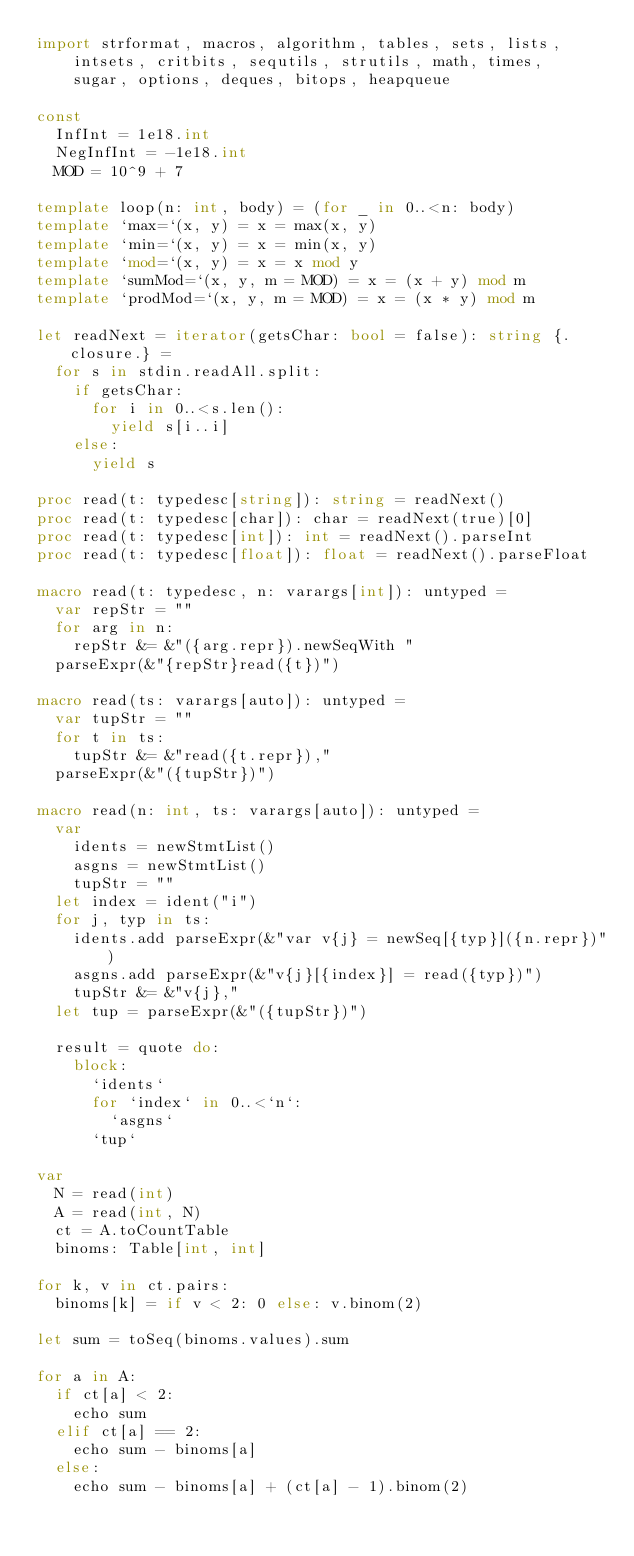Convert code to text. <code><loc_0><loc_0><loc_500><loc_500><_Nim_>import strformat, macros, algorithm, tables, sets, lists,
    intsets, critbits, sequtils, strutils, math, times,
    sugar, options, deques, bitops, heapqueue

const
  InfInt = 1e18.int
  NegInfInt = -1e18.int
  MOD = 10^9 + 7

template loop(n: int, body) = (for _ in 0..<n: body)
template `max=`(x, y) = x = max(x, y)
template `min=`(x, y) = x = min(x, y)
template `mod=`(x, y) = x = x mod y
template `sumMod=`(x, y, m = MOD) = x = (x + y) mod m
template `prodMod=`(x, y, m = MOD) = x = (x * y) mod m

let readNext = iterator(getsChar: bool = false): string {.closure.} =
  for s in stdin.readAll.split:
    if getsChar:
      for i in 0..<s.len():
        yield s[i..i]
    else:
      yield s

proc read(t: typedesc[string]): string = readNext()
proc read(t: typedesc[char]): char = readNext(true)[0]
proc read(t: typedesc[int]): int = readNext().parseInt
proc read(t: typedesc[float]): float = readNext().parseFloat

macro read(t: typedesc, n: varargs[int]): untyped =
  var repStr = ""
  for arg in n:
    repStr &= &"({arg.repr}).newSeqWith "
  parseExpr(&"{repStr}read({t})")

macro read(ts: varargs[auto]): untyped =
  var tupStr = ""
  for t in ts:
    tupStr &= &"read({t.repr}),"
  parseExpr(&"({tupStr})")

macro read(n: int, ts: varargs[auto]): untyped =
  var
    idents = newStmtList()
    asgns = newStmtList()
    tupStr = ""
  let index = ident("i")
  for j, typ in ts:
    idents.add parseExpr(&"var v{j} = newSeq[{typ}]({n.repr})")
    asgns.add parseExpr(&"v{j}[{index}] = read({typ})")
    tupStr &= &"v{j},"
  let tup = parseExpr(&"({tupStr})")

  result = quote do:
    block:
      `idents`
      for `index` in 0..<`n`:
        `asgns`
      `tup`

var
  N = read(int)
  A = read(int, N)
  ct = A.toCountTable
  binoms: Table[int, int]

for k, v in ct.pairs:
  binoms[k] = if v < 2: 0 else: v.binom(2)

let sum = toSeq(binoms.values).sum

for a in A:
  if ct[a] < 2:
    echo sum
  elif ct[a] == 2:
    echo sum - binoms[a]
  else:
    echo sum - binoms[a] + (ct[a] - 1).binom(2)
</code> 